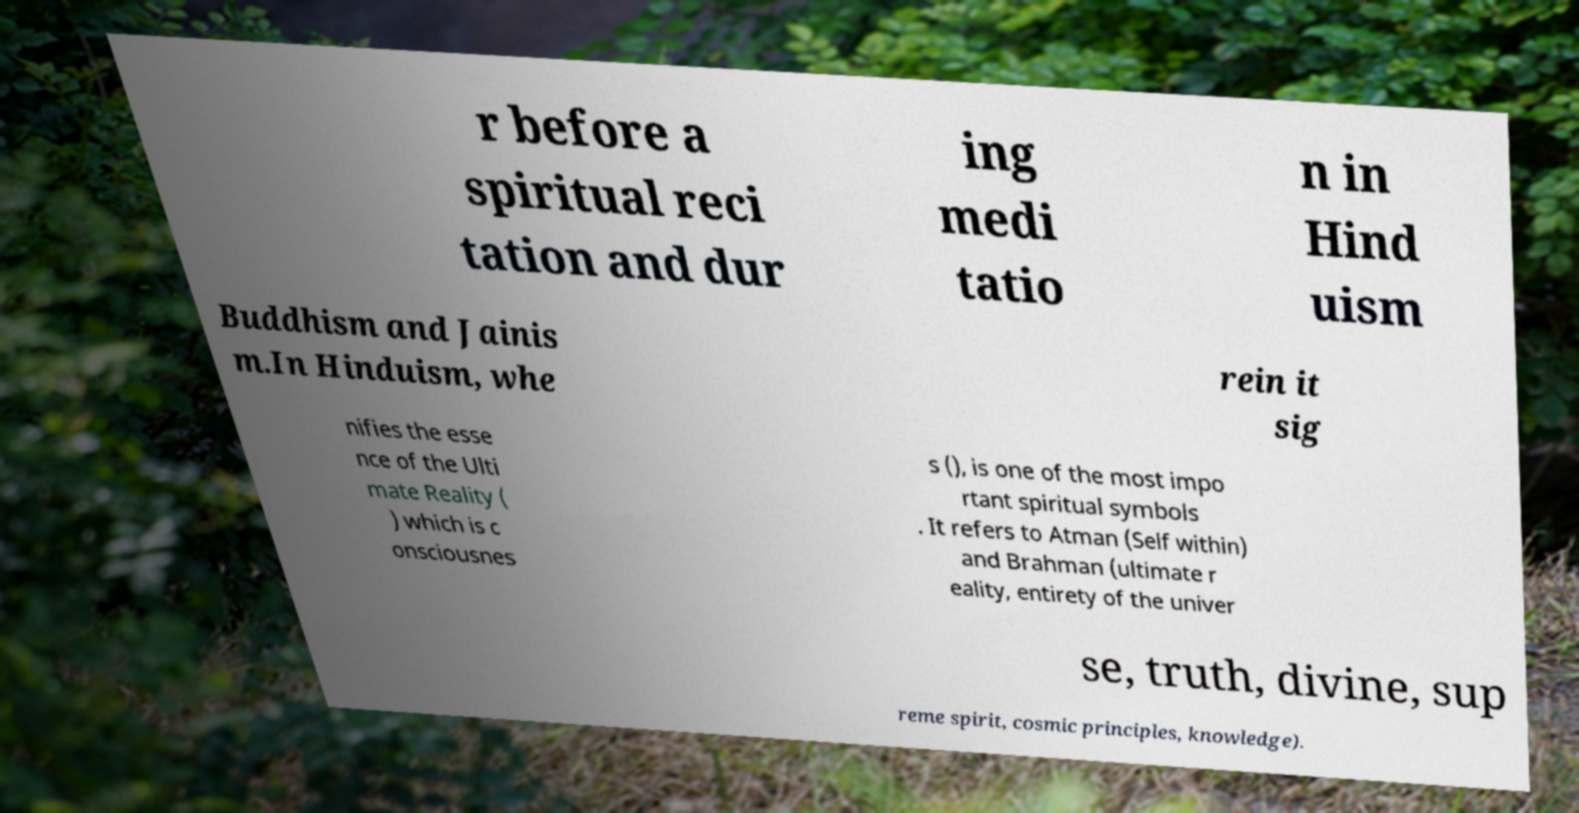There's text embedded in this image that I need extracted. Can you transcribe it verbatim? r before a spiritual reci tation and dur ing medi tatio n in Hind uism Buddhism and Jainis m.In Hinduism, whe rein it sig nifies the esse nce of the Ulti mate Reality ( ) which is c onsciousnes s (), is one of the most impo rtant spiritual symbols . It refers to Atman (Self within) and Brahman (ultimate r eality, entirety of the univer se, truth, divine, sup reme spirit, cosmic principles, knowledge). 